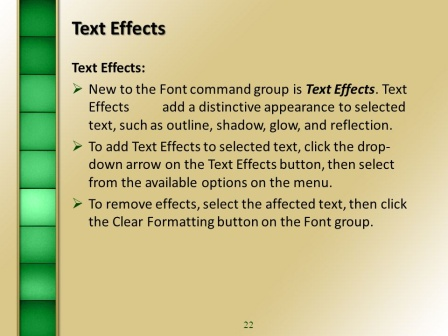Describe the following image. The image depicts a slide from a presentation, which is set against a soft green background. The main highlight of the slide is a white text box that spans most of the right side. At the top of this box, the heading "Text Effects" is prominently displayed, signaling the content that follows. Below the title are three bullet points that briefly explain the functionality of text effects in presentation software, specifically in the Font command group. These effects include outline, shadow, glow, and reflection, each adding a unique visual appeal to the text. Additionally, the points provide instructions on how to apply and remove these effects.

On the slide's left side, a vertical gradient bar adds an aesthetic touch, transitioning through various shades of green and creating a pleasing sense of depth. Finally, the number "22" is located at the bottom right corner, signifying this slide's place within the overall presentation sequence. The slide is well-organized, informative, and visually appealing, indicating it is part of a comprehensive guide on utilizing text effects in presentation software. 